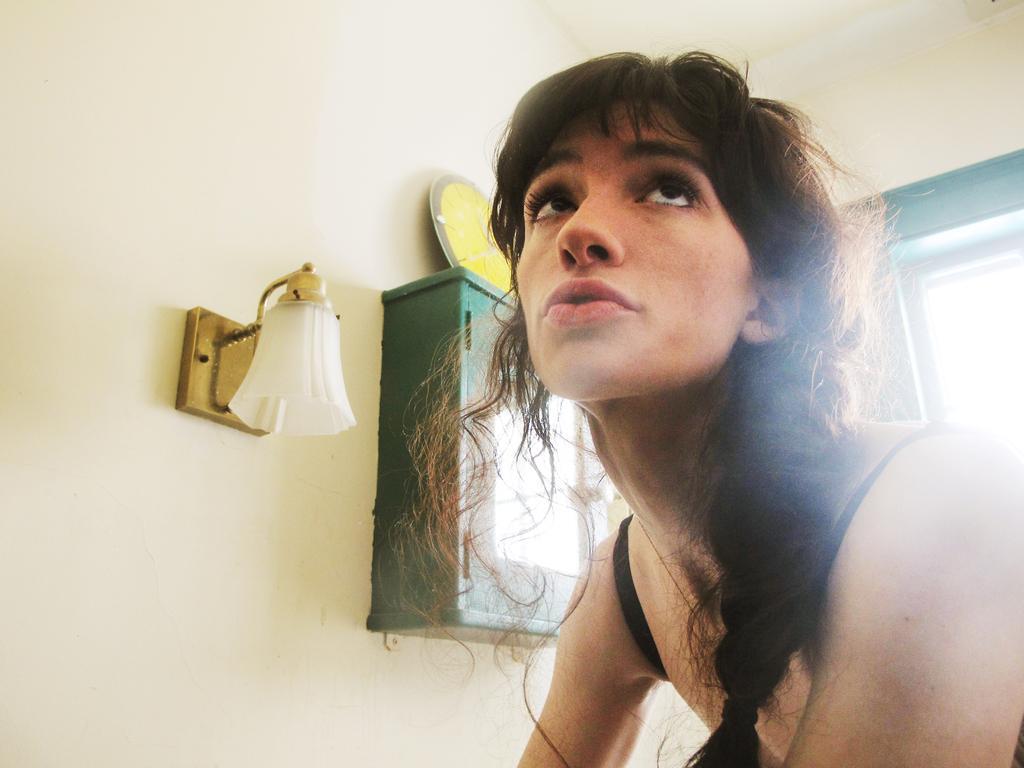In one or two sentences, can you explain what this image depicts? This person is looking upwards. Box and lamp is on the wall. Here we can see clock and window. 